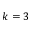<formula> <loc_0><loc_0><loc_500><loc_500>k = 3</formula> 